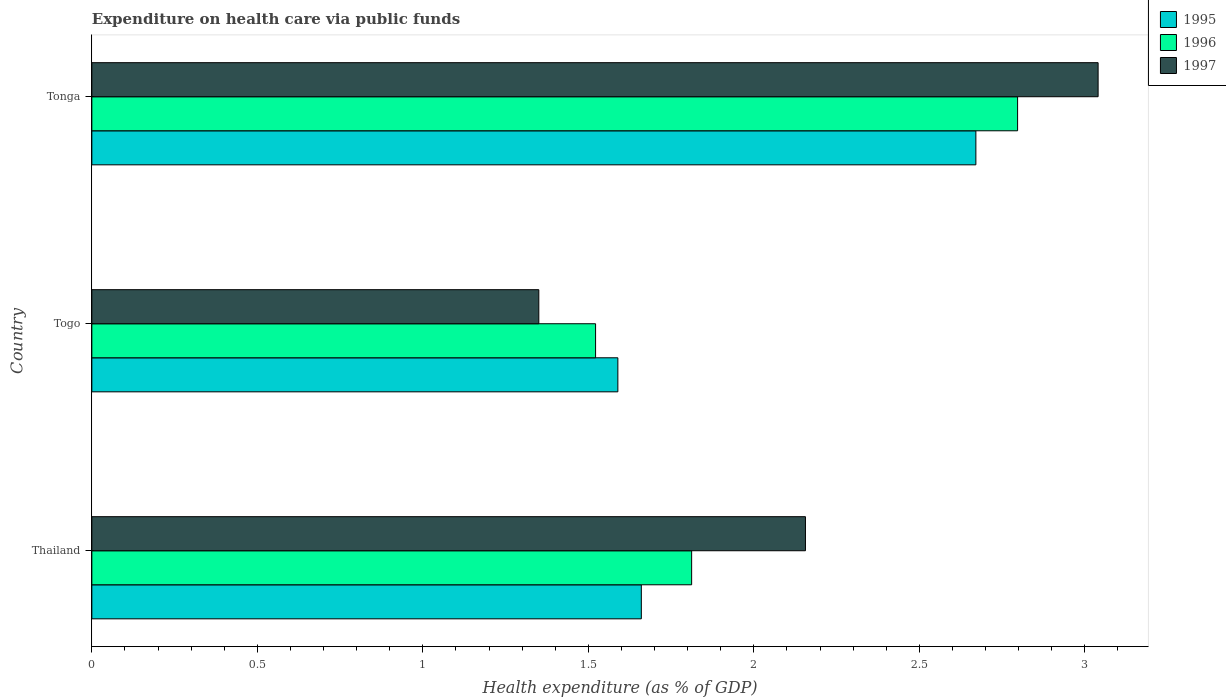How many different coloured bars are there?
Provide a short and direct response. 3. How many bars are there on the 3rd tick from the bottom?
Provide a short and direct response. 3. What is the label of the 3rd group of bars from the top?
Offer a terse response. Thailand. What is the expenditure made on health care in 1996 in Tonga?
Give a very brief answer. 2.8. Across all countries, what is the maximum expenditure made on health care in 1995?
Offer a very short reply. 2.67. Across all countries, what is the minimum expenditure made on health care in 1995?
Provide a short and direct response. 1.59. In which country was the expenditure made on health care in 1995 maximum?
Keep it short and to the point. Tonga. In which country was the expenditure made on health care in 1996 minimum?
Provide a short and direct response. Togo. What is the total expenditure made on health care in 1996 in the graph?
Provide a short and direct response. 6.13. What is the difference between the expenditure made on health care in 1996 in Thailand and that in Togo?
Offer a very short reply. 0.29. What is the difference between the expenditure made on health care in 1995 in Tonga and the expenditure made on health care in 1997 in Togo?
Provide a succinct answer. 1.32. What is the average expenditure made on health care in 1997 per country?
Your answer should be compact. 2.18. What is the difference between the expenditure made on health care in 1995 and expenditure made on health care in 1996 in Togo?
Make the answer very short. 0.07. What is the ratio of the expenditure made on health care in 1995 in Togo to that in Tonga?
Your answer should be compact. 0.6. Is the expenditure made on health care in 1995 in Togo less than that in Tonga?
Ensure brevity in your answer.  Yes. Is the difference between the expenditure made on health care in 1995 in Togo and Tonga greater than the difference between the expenditure made on health care in 1996 in Togo and Tonga?
Make the answer very short. Yes. What is the difference between the highest and the second highest expenditure made on health care in 1997?
Keep it short and to the point. 0.88. What is the difference between the highest and the lowest expenditure made on health care in 1997?
Make the answer very short. 1.69. Is the sum of the expenditure made on health care in 1995 in Togo and Tonga greater than the maximum expenditure made on health care in 1996 across all countries?
Offer a terse response. Yes. Is it the case that in every country, the sum of the expenditure made on health care in 1995 and expenditure made on health care in 1996 is greater than the expenditure made on health care in 1997?
Offer a very short reply. Yes. How many countries are there in the graph?
Keep it short and to the point. 3. What is the difference between two consecutive major ticks on the X-axis?
Make the answer very short. 0.5. Does the graph contain grids?
Ensure brevity in your answer.  No. How are the legend labels stacked?
Make the answer very short. Vertical. What is the title of the graph?
Ensure brevity in your answer.  Expenditure on health care via public funds. What is the label or title of the X-axis?
Keep it short and to the point. Health expenditure (as % of GDP). What is the label or title of the Y-axis?
Provide a short and direct response. Country. What is the Health expenditure (as % of GDP) in 1995 in Thailand?
Your response must be concise. 1.66. What is the Health expenditure (as % of GDP) in 1996 in Thailand?
Provide a succinct answer. 1.81. What is the Health expenditure (as % of GDP) of 1997 in Thailand?
Offer a very short reply. 2.16. What is the Health expenditure (as % of GDP) of 1995 in Togo?
Your answer should be compact. 1.59. What is the Health expenditure (as % of GDP) of 1996 in Togo?
Your answer should be very brief. 1.52. What is the Health expenditure (as % of GDP) of 1997 in Togo?
Your answer should be very brief. 1.35. What is the Health expenditure (as % of GDP) in 1995 in Tonga?
Your response must be concise. 2.67. What is the Health expenditure (as % of GDP) in 1996 in Tonga?
Offer a terse response. 2.8. What is the Health expenditure (as % of GDP) in 1997 in Tonga?
Your answer should be very brief. 3.04. Across all countries, what is the maximum Health expenditure (as % of GDP) in 1995?
Ensure brevity in your answer.  2.67. Across all countries, what is the maximum Health expenditure (as % of GDP) of 1996?
Your answer should be compact. 2.8. Across all countries, what is the maximum Health expenditure (as % of GDP) in 1997?
Your response must be concise. 3.04. Across all countries, what is the minimum Health expenditure (as % of GDP) of 1995?
Offer a very short reply. 1.59. Across all countries, what is the minimum Health expenditure (as % of GDP) of 1996?
Your answer should be very brief. 1.52. Across all countries, what is the minimum Health expenditure (as % of GDP) in 1997?
Ensure brevity in your answer.  1.35. What is the total Health expenditure (as % of GDP) of 1995 in the graph?
Provide a succinct answer. 5.92. What is the total Health expenditure (as % of GDP) of 1996 in the graph?
Your response must be concise. 6.13. What is the total Health expenditure (as % of GDP) of 1997 in the graph?
Provide a short and direct response. 6.55. What is the difference between the Health expenditure (as % of GDP) in 1995 in Thailand and that in Togo?
Your answer should be very brief. 0.07. What is the difference between the Health expenditure (as % of GDP) in 1996 in Thailand and that in Togo?
Offer a very short reply. 0.29. What is the difference between the Health expenditure (as % of GDP) in 1997 in Thailand and that in Togo?
Your answer should be very brief. 0.81. What is the difference between the Health expenditure (as % of GDP) of 1995 in Thailand and that in Tonga?
Provide a succinct answer. -1.01. What is the difference between the Health expenditure (as % of GDP) in 1996 in Thailand and that in Tonga?
Your answer should be very brief. -0.98. What is the difference between the Health expenditure (as % of GDP) of 1997 in Thailand and that in Tonga?
Keep it short and to the point. -0.88. What is the difference between the Health expenditure (as % of GDP) of 1995 in Togo and that in Tonga?
Make the answer very short. -1.08. What is the difference between the Health expenditure (as % of GDP) in 1996 in Togo and that in Tonga?
Make the answer very short. -1.27. What is the difference between the Health expenditure (as % of GDP) in 1997 in Togo and that in Tonga?
Make the answer very short. -1.69. What is the difference between the Health expenditure (as % of GDP) of 1995 in Thailand and the Health expenditure (as % of GDP) of 1996 in Togo?
Ensure brevity in your answer.  0.14. What is the difference between the Health expenditure (as % of GDP) in 1995 in Thailand and the Health expenditure (as % of GDP) in 1997 in Togo?
Provide a short and direct response. 0.31. What is the difference between the Health expenditure (as % of GDP) of 1996 in Thailand and the Health expenditure (as % of GDP) of 1997 in Togo?
Make the answer very short. 0.46. What is the difference between the Health expenditure (as % of GDP) in 1995 in Thailand and the Health expenditure (as % of GDP) in 1996 in Tonga?
Ensure brevity in your answer.  -1.14. What is the difference between the Health expenditure (as % of GDP) of 1995 in Thailand and the Health expenditure (as % of GDP) of 1997 in Tonga?
Provide a succinct answer. -1.38. What is the difference between the Health expenditure (as % of GDP) of 1996 in Thailand and the Health expenditure (as % of GDP) of 1997 in Tonga?
Offer a terse response. -1.23. What is the difference between the Health expenditure (as % of GDP) of 1995 in Togo and the Health expenditure (as % of GDP) of 1996 in Tonga?
Provide a succinct answer. -1.21. What is the difference between the Health expenditure (as % of GDP) of 1995 in Togo and the Health expenditure (as % of GDP) of 1997 in Tonga?
Ensure brevity in your answer.  -1.45. What is the difference between the Health expenditure (as % of GDP) in 1996 in Togo and the Health expenditure (as % of GDP) in 1997 in Tonga?
Make the answer very short. -1.52. What is the average Health expenditure (as % of GDP) in 1995 per country?
Offer a very short reply. 1.97. What is the average Health expenditure (as % of GDP) in 1996 per country?
Give a very brief answer. 2.04. What is the average Health expenditure (as % of GDP) in 1997 per country?
Make the answer very short. 2.18. What is the difference between the Health expenditure (as % of GDP) of 1995 and Health expenditure (as % of GDP) of 1996 in Thailand?
Give a very brief answer. -0.15. What is the difference between the Health expenditure (as % of GDP) in 1995 and Health expenditure (as % of GDP) in 1997 in Thailand?
Make the answer very short. -0.5. What is the difference between the Health expenditure (as % of GDP) of 1996 and Health expenditure (as % of GDP) of 1997 in Thailand?
Keep it short and to the point. -0.34. What is the difference between the Health expenditure (as % of GDP) in 1995 and Health expenditure (as % of GDP) in 1996 in Togo?
Your answer should be compact. 0.07. What is the difference between the Health expenditure (as % of GDP) in 1995 and Health expenditure (as % of GDP) in 1997 in Togo?
Offer a terse response. 0.24. What is the difference between the Health expenditure (as % of GDP) of 1996 and Health expenditure (as % of GDP) of 1997 in Togo?
Give a very brief answer. 0.17. What is the difference between the Health expenditure (as % of GDP) in 1995 and Health expenditure (as % of GDP) in 1996 in Tonga?
Make the answer very short. -0.13. What is the difference between the Health expenditure (as % of GDP) in 1995 and Health expenditure (as % of GDP) in 1997 in Tonga?
Your answer should be compact. -0.37. What is the difference between the Health expenditure (as % of GDP) of 1996 and Health expenditure (as % of GDP) of 1997 in Tonga?
Provide a succinct answer. -0.24. What is the ratio of the Health expenditure (as % of GDP) in 1995 in Thailand to that in Togo?
Provide a short and direct response. 1.04. What is the ratio of the Health expenditure (as % of GDP) in 1996 in Thailand to that in Togo?
Keep it short and to the point. 1.19. What is the ratio of the Health expenditure (as % of GDP) in 1997 in Thailand to that in Togo?
Your answer should be compact. 1.6. What is the ratio of the Health expenditure (as % of GDP) in 1995 in Thailand to that in Tonga?
Ensure brevity in your answer.  0.62. What is the ratio of the Health expenditure (as % of GDP) of 1996 in Thailand to that in Tonga?
Provide a short and direct response. 0.65. What is the ratio of the Health expenditure (as % of GDP) in 1997 in Thailand to that in Tonga?
Give a very brief answer. 0.71. What is the ratio of the Health expenditure (as % of GDP) in 1995 in Togo to that in Tonga?
Your answer should be compact. 0.59. What is the ratio of the Health expenditure (as % of GDP) in 1996 in Togo to that in Tonga?
Give a very brief answer. 0.54. What is the ratio of the Health expenditure (as % of GDP) of 1997 in Togo to that in Tonga?
Make the answer very short. 0.44. What is the difference between the highest and the second highest Health expenditure (as % of GDP) of 1995?
Offer a terse response. 1.01. What is the difference between the highest and the second highest Health expenditure (as % of GDP) of 1997?
Make the answer very short. 0.88. What is the difference between the highest and the lowest Health expenditure (as % of GDP) in 1995?
Give a very brief answer. 1.08. What is the difference between the highest and the lowest Health expenditure (as % of GDP) in 1996?
Offer a terse response. 1.27. What is the difference between the highest and the lowest Health expenditure (as % of GDP) in 1997?
Your response must be concise. 1.69. 